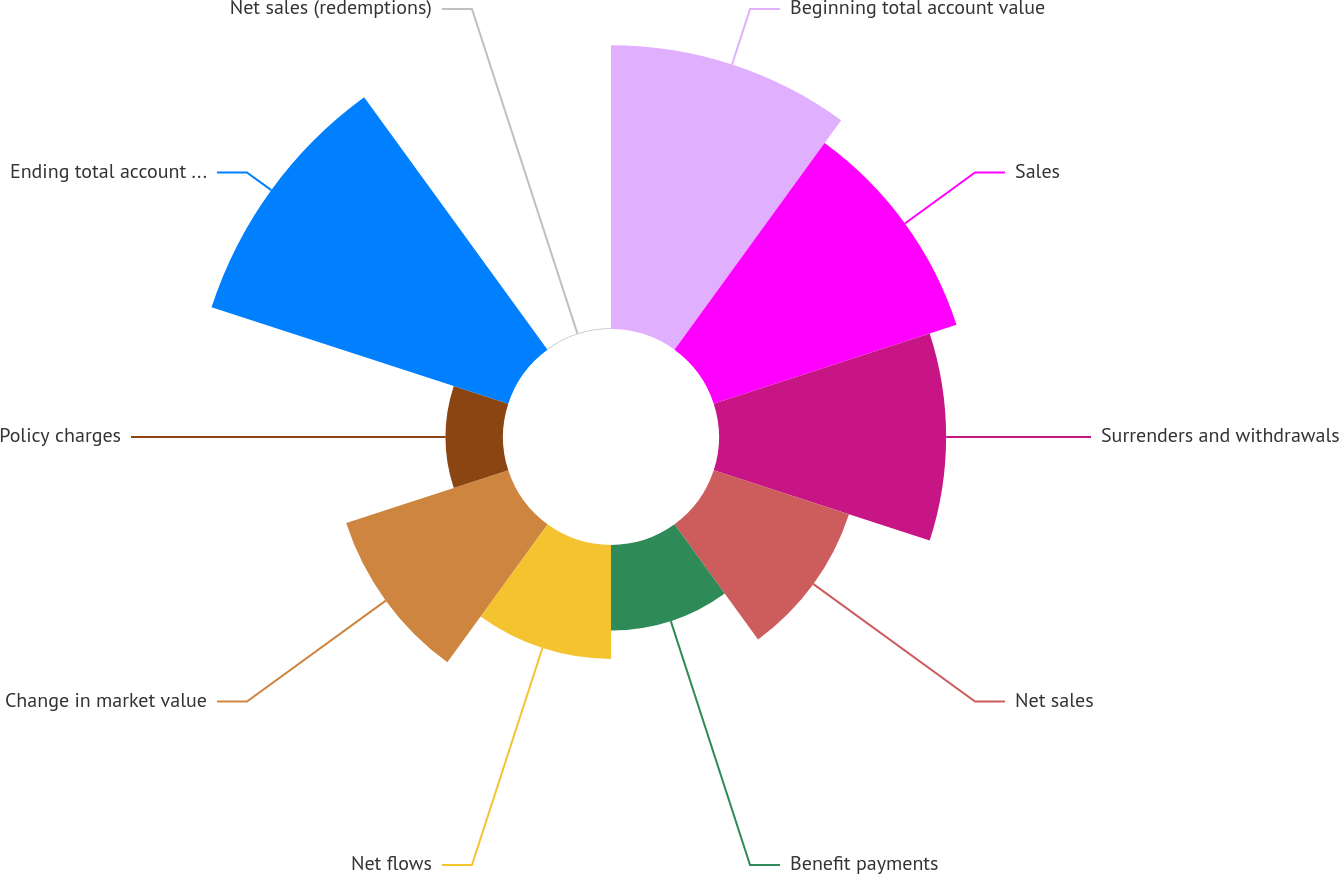Convert chart. <chart><loc_0><loc_0><loc_500><loc_500><pie_chart><fcel>Beginning total account value<fcel>Sales<fcel>Surrenders and withdrawals<fcel>Net sales<fcel>Benefit payments<fcel>Net flows<fcel>Change in market value<fcel>Policy charges<fcel>Ending total account value (2)<fcel>Net sales (redemptions)<nl><fcel>17.21%<fcel>15.49%<fcel>13.78%<fcel>8.63%<fcel>5.19%<fcel>6.91%<fcel>10.34%<fcel>3.48%<fcel>18.93%<fcel>0.04%<nl></chart> 